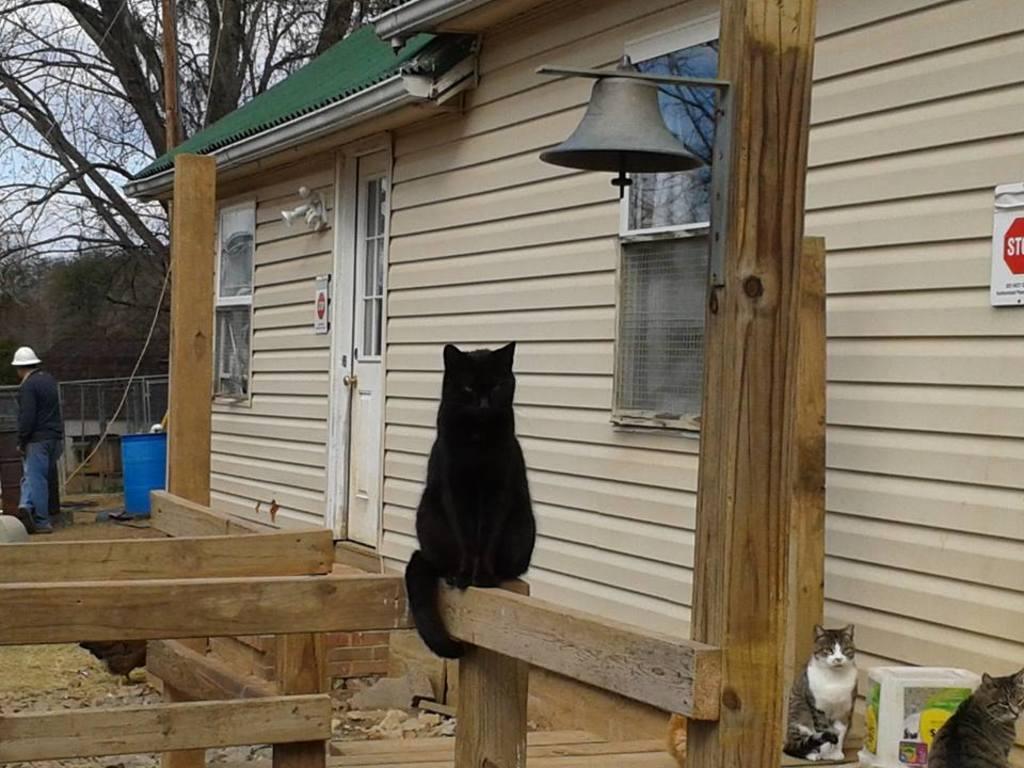Can you describe this image briefly? In the middle of the image there is a cat on a wooden fencing. Behind the cat there is a house, on the house there is a sign board and windows and door. In the bottom right corner of the image there are two cats. On the left side of the image a person is standing and there is a bucket. Behind them there is fencing and there are some trees. Behind the trees there is sky. 